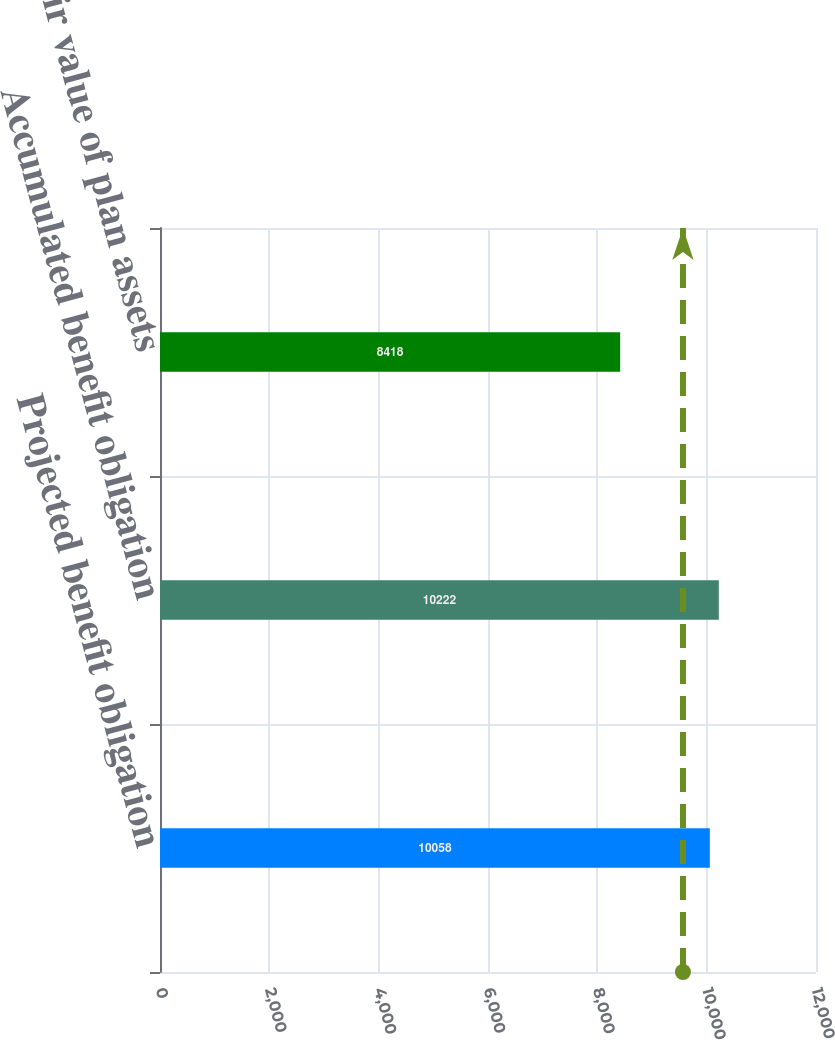Convert chart to OTSL. <chart><loc_0><loc_0><loc_500><loc_500><bar_chart><fcel>Projected benefit obligation<fcel>Accumulated benefit obligation<fcel>Fair value of plan assets<nl><fcel>10058<fcel>10222<fcel>8418<nl></chart> 